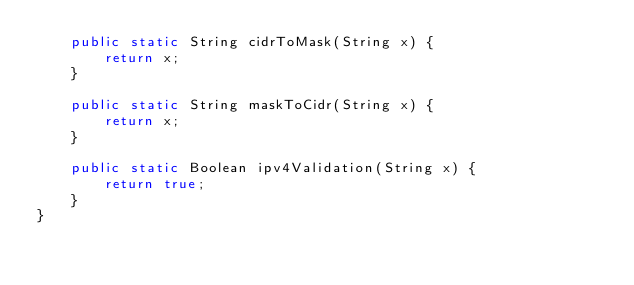Convert code to text. <code><loc_0><loc_0><loc_500><loc_500><_Java_>    public static String cidrToMask(String x) {
        return x;
    }

    public static String maskToCidr(String x) {
        return x;
    }

    public static Boolean ipv4Validation(String x) {
        return true;
    }
}
</code> 